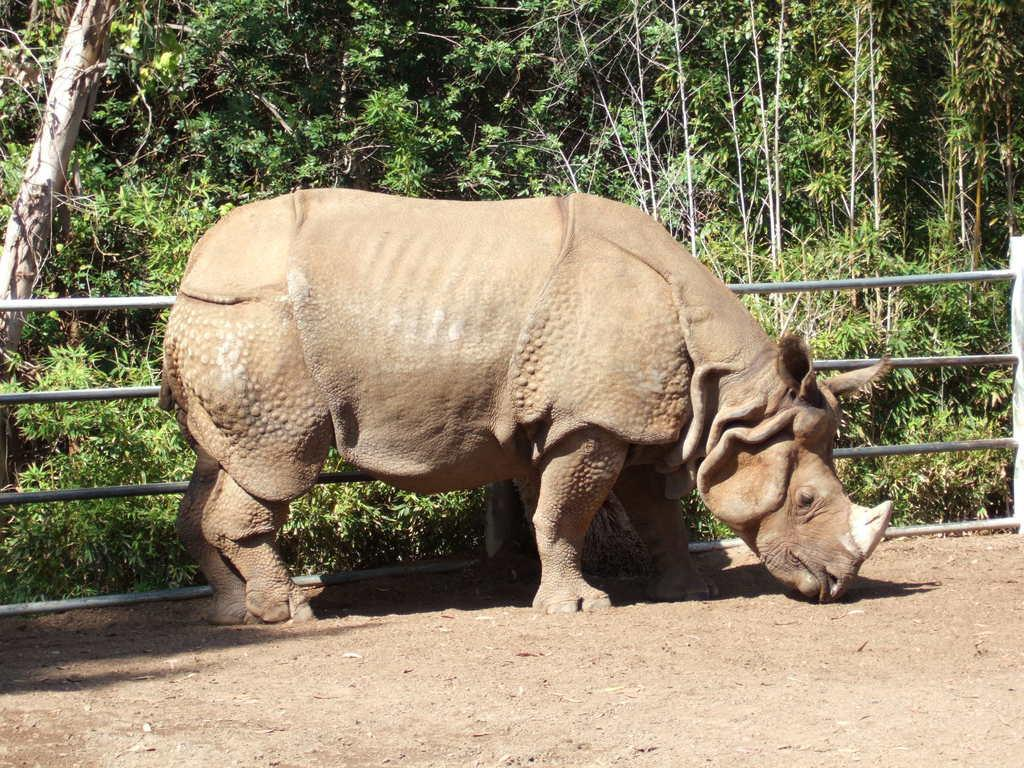What animal is the main subject of the picture? There is a rhinoceros in the picture. What can be seen in the background of the picture? There is a fence, plants, and trees in the backdrop of the picture. What type of coal is being used by the rhinoceros in the picture? There is no coal present in the image; it features a rhinoceros and a background with a fence, plants, and trees. 